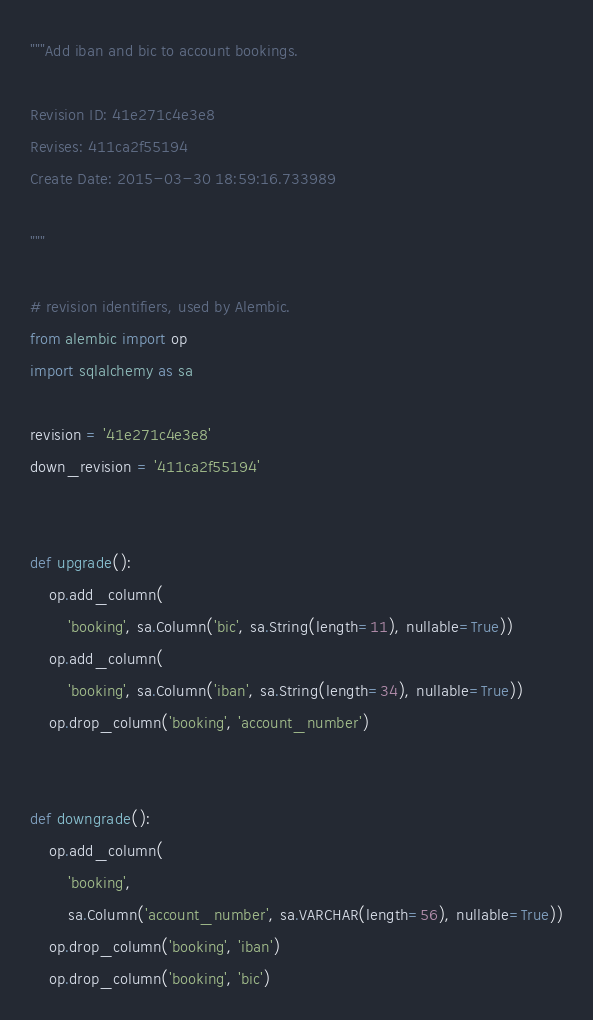Convert code to text. <code><loc_0><loc_0><loc_500><loc_500><_Python_>"""Add iban and bic to account bookings.

Revision ID: 41e271c4e3e8
Revises: 411ca2f55194
Create Date: 2015-03-30 18:59:16.733989

"""

# revision identifiers, used by Alembic.
from alembic import op
import sqlalchemy as sa

revision = '41e271c4e3e8'
down_revision = '411ca2f55194'


def upgrade():
    op.add_column(
        'booking', sa.Column('bic', sa.String(length=11), nullable=True))
    op.add_column(
        'booking', sa.Column('iban', sa.String(length=34), nullable=True))
    op.drop_column('booking', 'account_number')


def downgrade():
    op.add_column(
        'booking',
        sa.Column('account_number', sa.VARCHAR(length=56), nullable=True))
    op.drop_column('booking', 'iban')
    op.drop_column('booking', 'bic')
</code> 